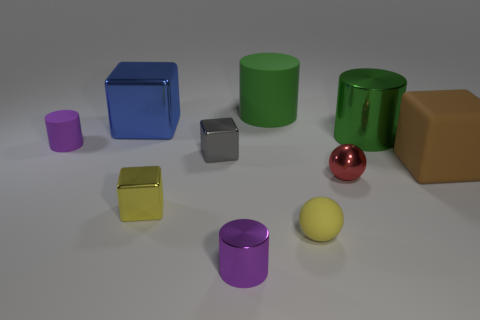Subtract all blue cubes. How many cubes are left? 3 Subtract all large brown rubber cubes. How many cubes are left? 3 Subtract 1 yellow blocks. How many objects are left? 9 Subtract all cylinders. How many objects are left? 6 Subtract 4 blocks. How many blocks are left? 0 Subtract all red blocks. Subtract all cyan cylinders. How many blocks are left? 4 Subtract all cyan balls. How many brown cubes are left? 1 Subtract all small purple metal cubes. Subtract all large green matte cylinders. How many objects are left? 9 Add 8 big brown blocks. How many big brown blocks are left? 9 Add 3 big green matte spheres. How many big green matte spheres exist? 3 